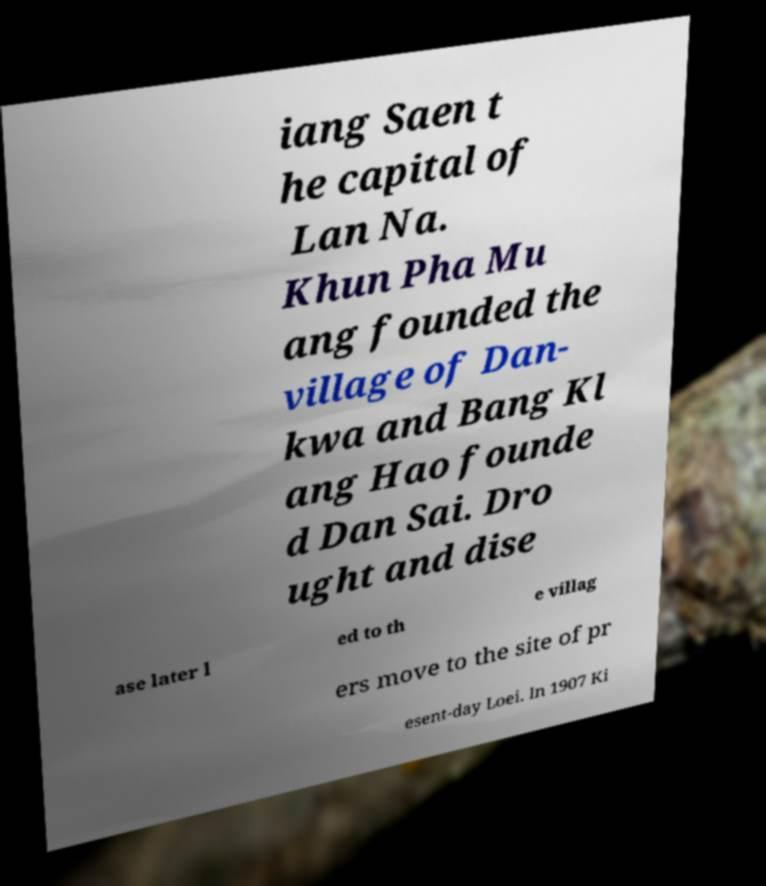There's text embedded in this image that I need extracted. Can you transcribe it verbatim? iang Saen t he capital of Lan Na. Khun Pha Mu ang founded the village of Dan- kwa and Bang Kl ang Hao founde d Dan Sai. Dro ught and dise ase later l ed to th e villag ers move to the site of pr esent-day Loei. In 1907 Ki 